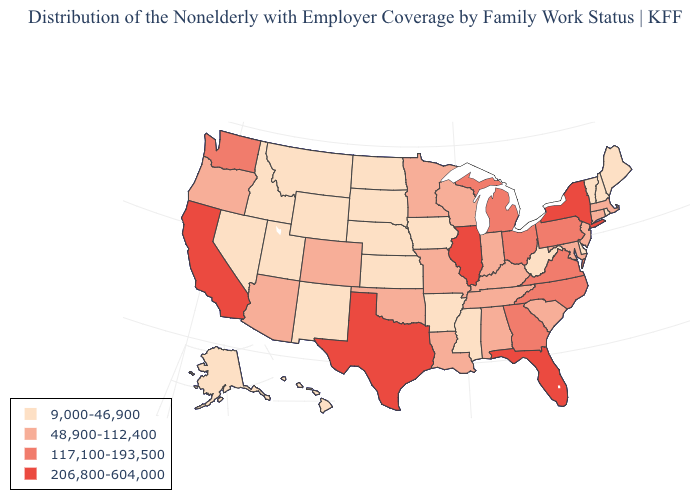Does Maine have the lowest value in the USA?
Keep it brief. Yes. Name the states that have a value in the range 48,900-112,400?
Answer briefly. Alabama, Arizona, Colorado, Connecticut, Indiana, Kentucky, Louisiana, Maryland, Massachusetts, Minnesota, Missouri, New Jersey, Oklahoma, Oregon, South Carolina, Tennessee, Wisconsin. Name the states that have a value in the range 9,000-46,900?
Answer briefly. Alaska, Arkansas, Delaware, Hawaii, Idaho, Iowa, Kansas, Maine, Mississippi, Montana, Nebraska, Nevada, New Hampshire, New Mexico, North Dakota, Rhode Island, South Dakota, Utah, Vermont, West Virginia, Wyoming. Name the states that have a value in the range 117,100-193,500?
Keep it brief. Georgia, Michigan, North Carolina, Ohio, Pennsylvania, Virginia, Washington. Does Idaho have the lowest value in the USA?
Keep it brief. Yes. Name the states that have a value in the range 117,100-193,500?
Be succinct. Georgia, Michigan, North Carolina, Ohio, Pennsylvania, Virginia, Washington. Name the states that have a value in the range 206,800-604,000?
Be succinct. California, Florida, Illinois, New York, Texas. Among the states that border Maine , which have the lowest value?
Short answer required. New Hampshire. Is the legend a continuous bar?
Answer briefly. No. What is the value of Georgia?
Concise answer only. 117,100-193,500. Does Minnesota have the same value as Arkansas?
Be succinct. No. Among the states that border West Virginia , which have the highest value?
Be succinct. Ohio, Pennsylvania, Virginia. Does the first symbol in the legend represent the smallest category?
Answer briefly. Yes. What is the lowest value in the USA?
Concise answer only. 9,000-46,900. What is the highest value in the West ?
Be succinct. 206,800-604,000. 